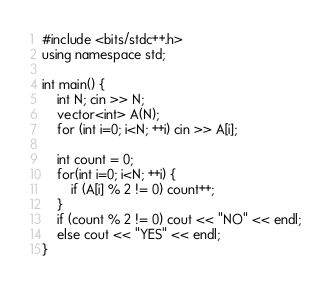<code> <loc_0><loc_0><loc_500><loc_500><_C++_>#include <bits/stdc++.h>
using namespace std;

int main() {
    int N; cin >> N;
    vector<int> A(N);
    for (int i=0; i<N; ++i) cin >> A[i];

    int count = 0;
    for(int i=0; i<N; ++i) {
        if (A[i] % 2 != 0) count++;
    }
    if (count % 2 != 0) cout << "NO" << endl;
    else cout << "YES" << endl;
}</code> 